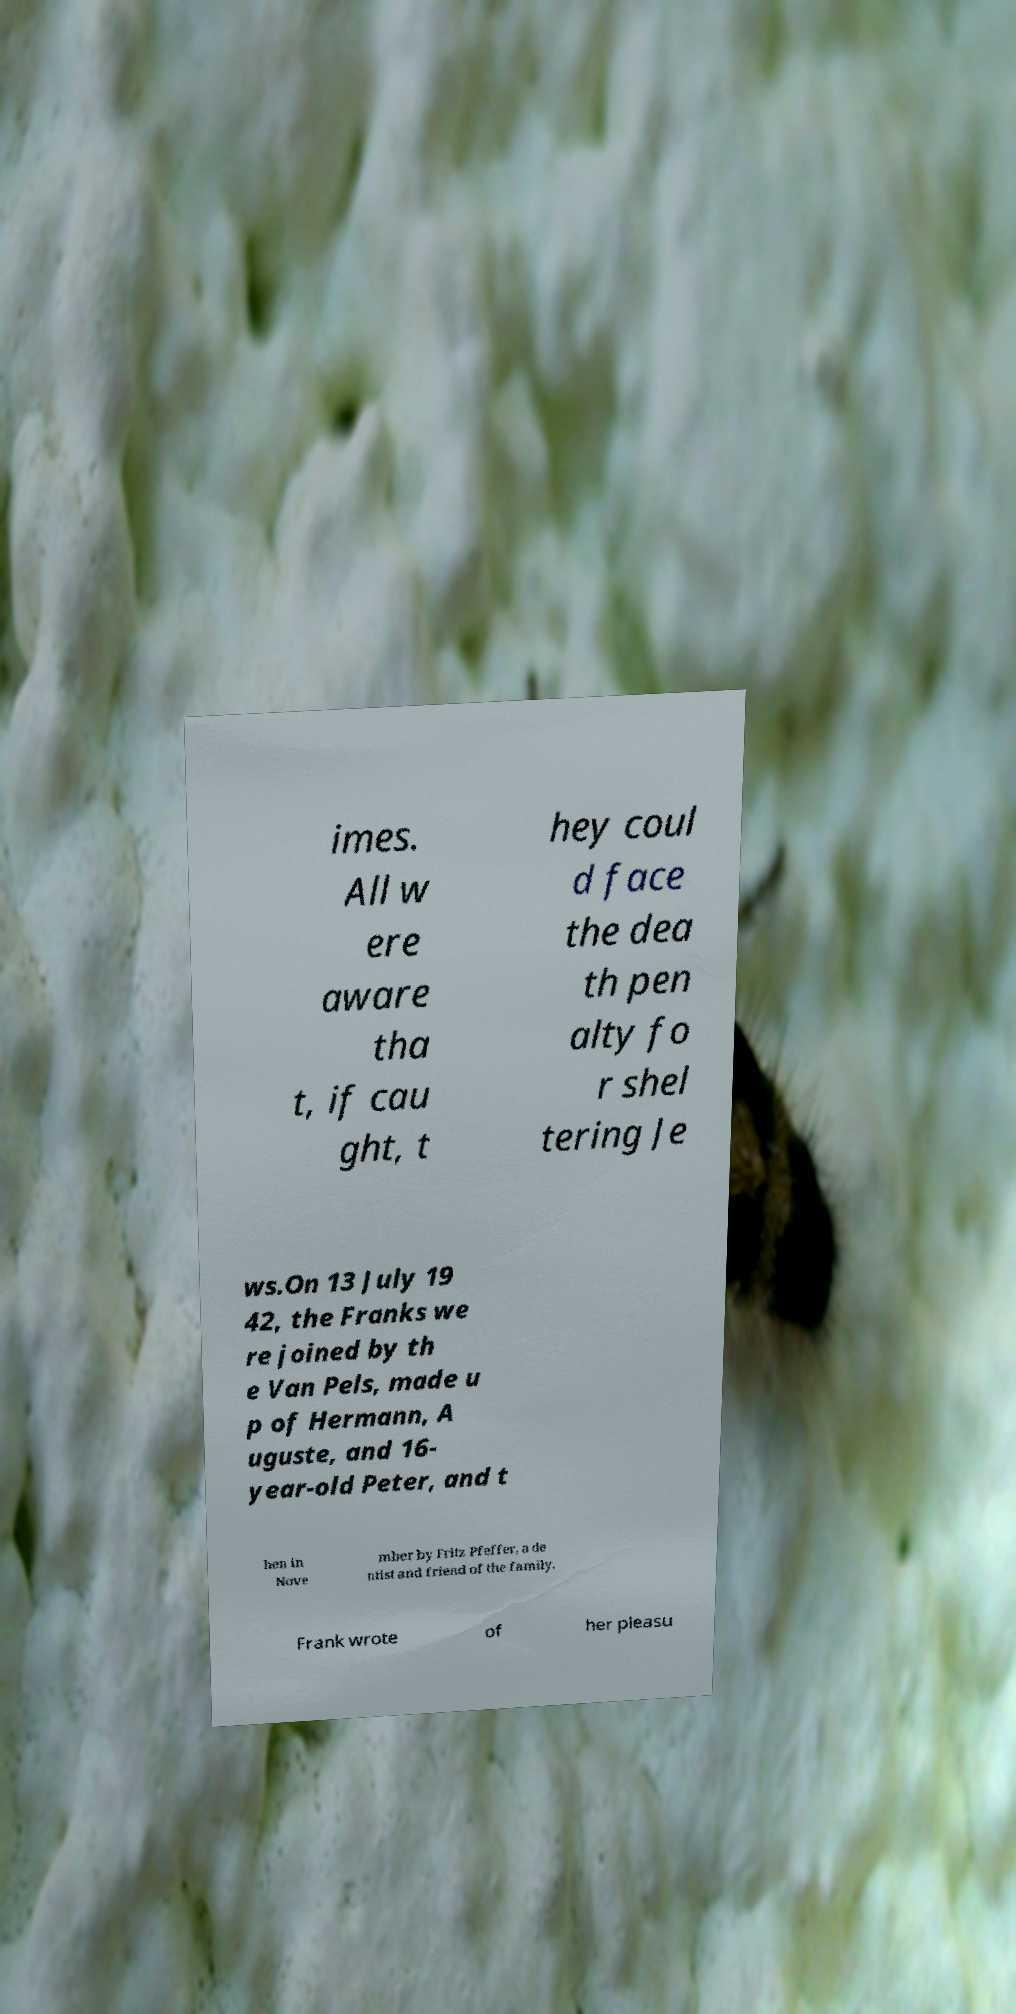Please read and relay the text visible in this image. What does it say? imes. All w ere aware tha t, if cau ght, t hey coul d face the dea th pen alty fo r shel tering Je ws.On 13 July 19 42, the Franks we re joined by th e Van Pels, made u p of Hermann, A uguste, and 16- year-old Peter, and t hen in Nove mber by Fritz Pfeffer, a de ntist and friend of the family. Frank wrote of her pleasu 